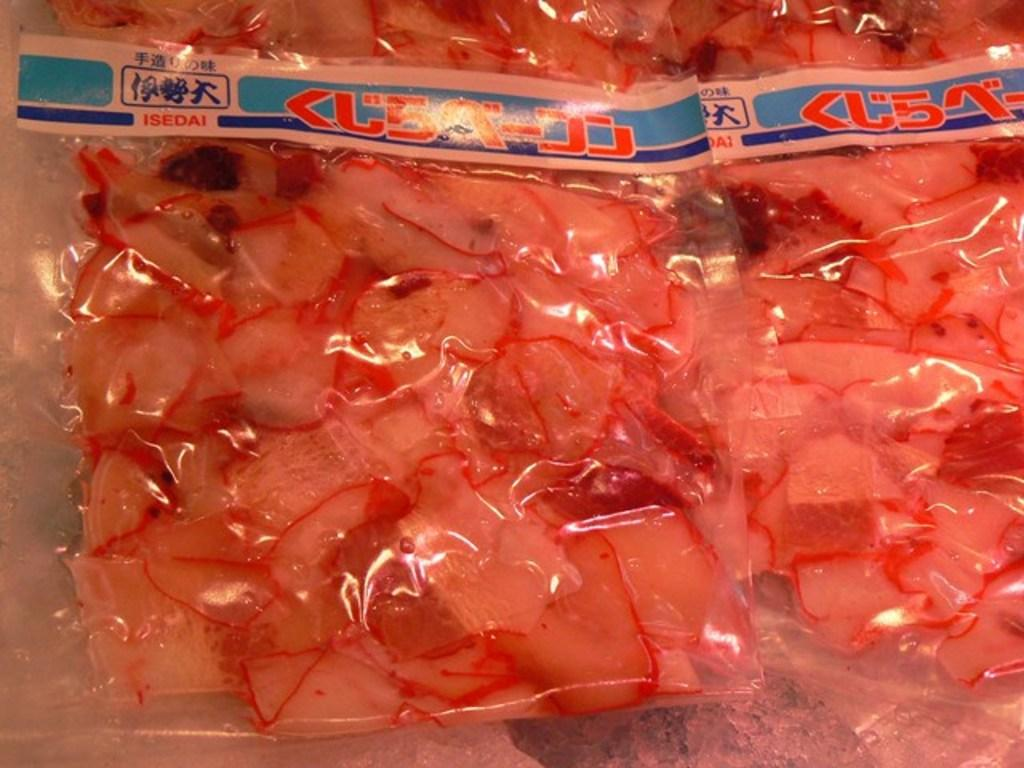What can be seen in the image that contains food items? There are packets in the image that contain food items. Can you describe the contents of the packets? The packets contain food items, but the specific types of food cannot be determined from the image. What type of brass instrument is being played by the person wearing a shirt in the image? There is no person wearing a shirt or playing a brass instrument in the image; it only shows packets containing food items. 